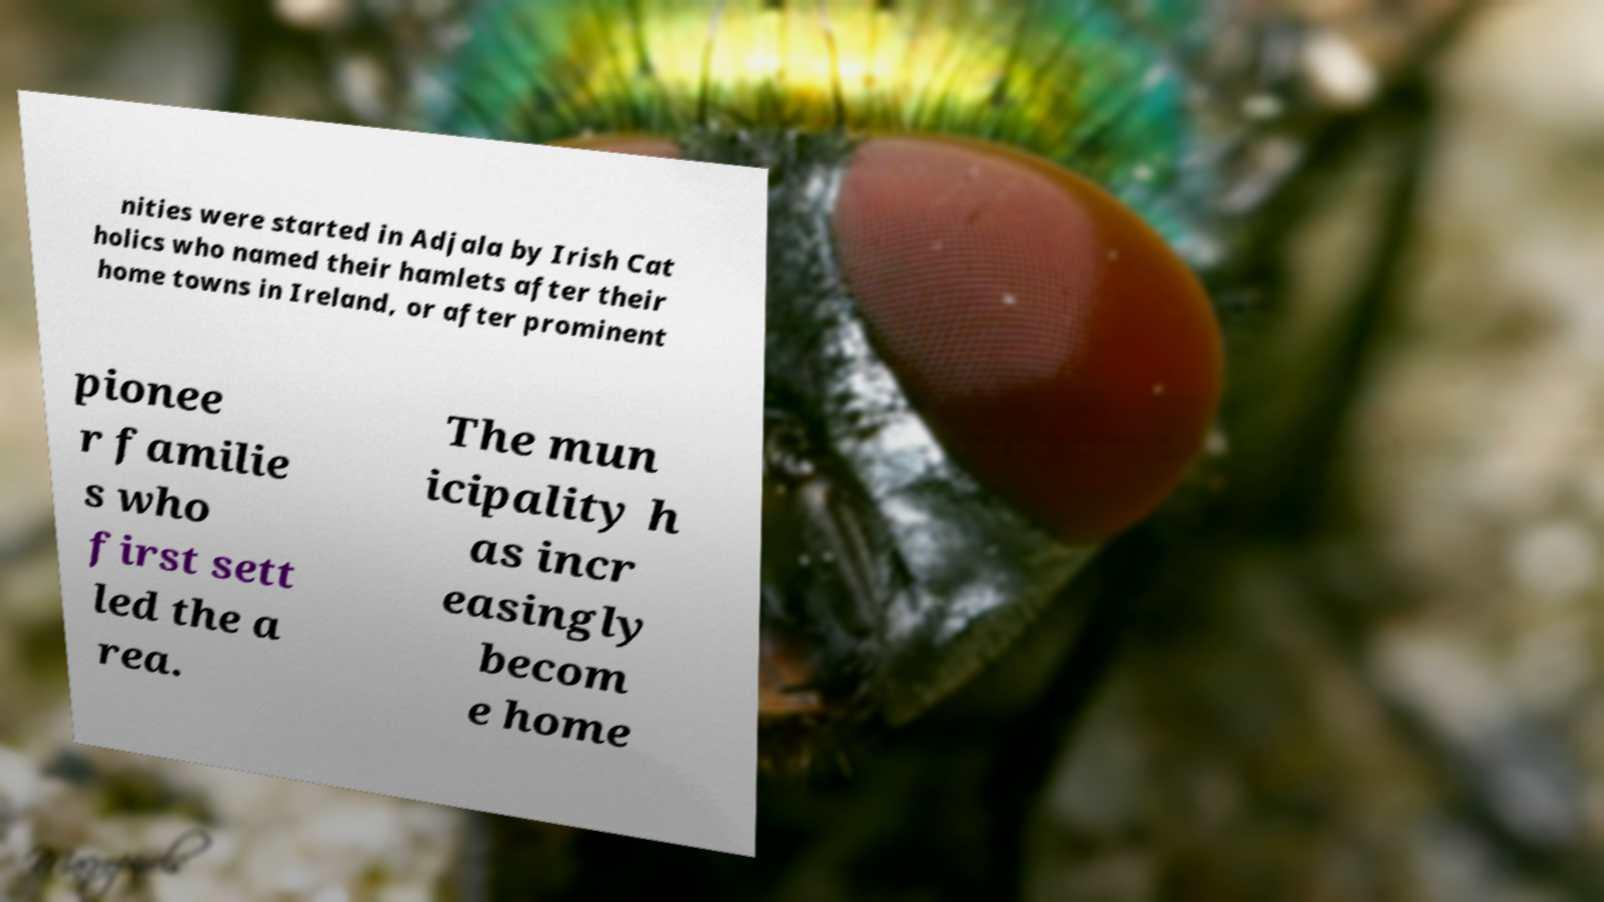What messages or text are displayed in this image? I need them in a readable, typed format. nities were started in Adjala by Irish Cat holics who named their hamlets after their home towns in Ireland, or after prominent pionee r familie s who first sett led the a rea. The mun icipality h as incr easingly becom e home 